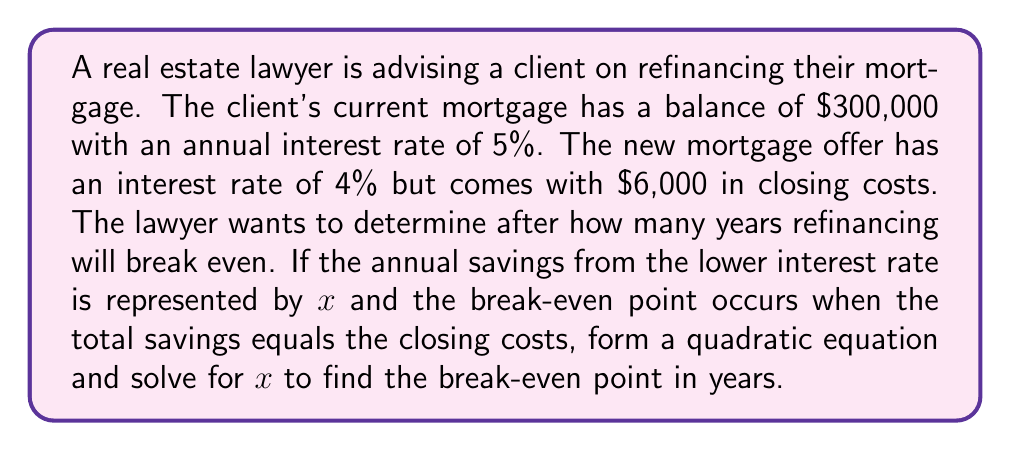Solve this math problem. To solve this problem, we'll follow these steps:

1) First, let's calculate the annual savings:
   Current annual interest: $300,000 \times 0.05 = $15,000
   New annual interest: $300,000 \times 0.04 = $12,000
   Annual savings: $15,000 - $12,000 = $3,000

2) Now, let's form our quadratic equation. The total savings over $x$ years should equal the closing costs:
   $3,000x = 6,000$

3) This is actually a linear equation, not a quadratic. We can solve it directly:
   $$x = \frac{6,000}{3,000} = 2$$

4) Therefore, the break-even point is 2 years.

5) To verify and create a quadratic equation as requested, we can consider the time value of money. If we assume the savings are reinvested at the new interest rate (4%), we get:
   $$3,000 \cdot \frac{(1+0.04)^x - 1}{0.04} = 6,000$$

6) This can be expanded to:
   $$3,000 \cdot \frac{1.04^x - 1}{0.04} = 6,000$$

7) Multiplying both sides by 0.04:
   $$3,000 \cdot (1.04^x - 1) = 240$$

8) Dividing by 3,000:
   $$1.04^x - 1 = 0.08$$

9) Adding 1 to both sides:
   $$1.04^x = 1.08$$

10) Taking the natural log of both sides:
    $$x \cdot \ln(1.04) = \ln(1.08)$$

11) Solving for $x$:
    $$x = \frac{\ln(1.08)}{\ln(1.04)} \approx 2.02$$

This more precise calculation confirms our initial result of approximately 2 years.
Answer: The break-even point for refinancing the mortgage is approximately 2 years. 